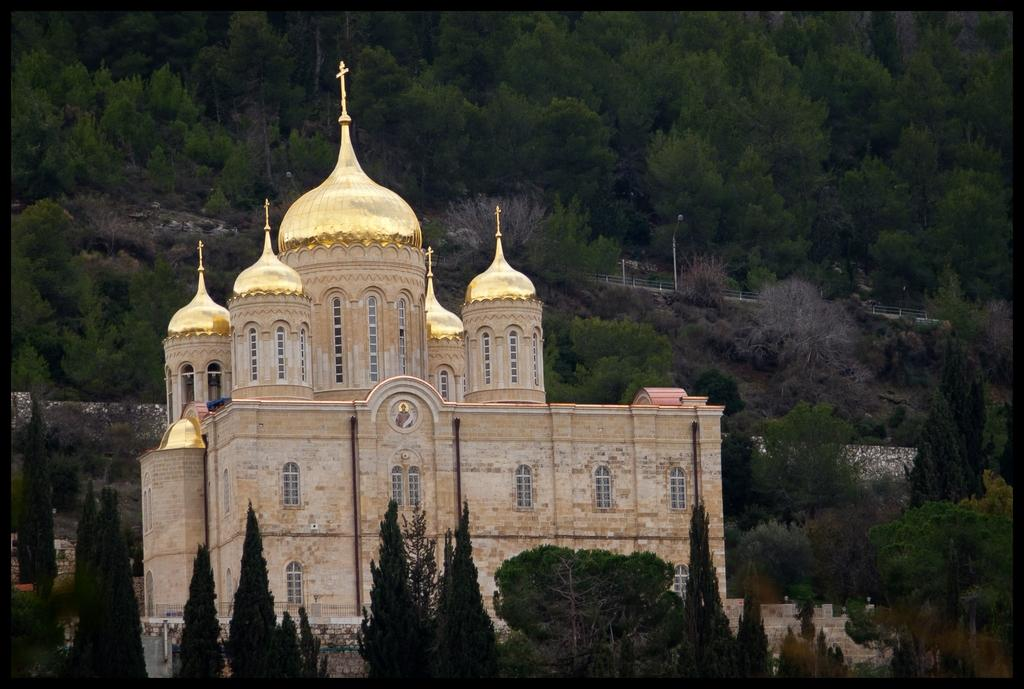What is the main structure in the middle of the image? There is a brown color church in the middle of the image. What feature can be seen on top of the church? The church has golden domes on top. What can be seen in the background of the image? There are many trees on a hill in the background of the image. What type of food is being served in the church in the image? There is no food being served in the church in the image. The image only shows the church with golden domes and trees in the background. 